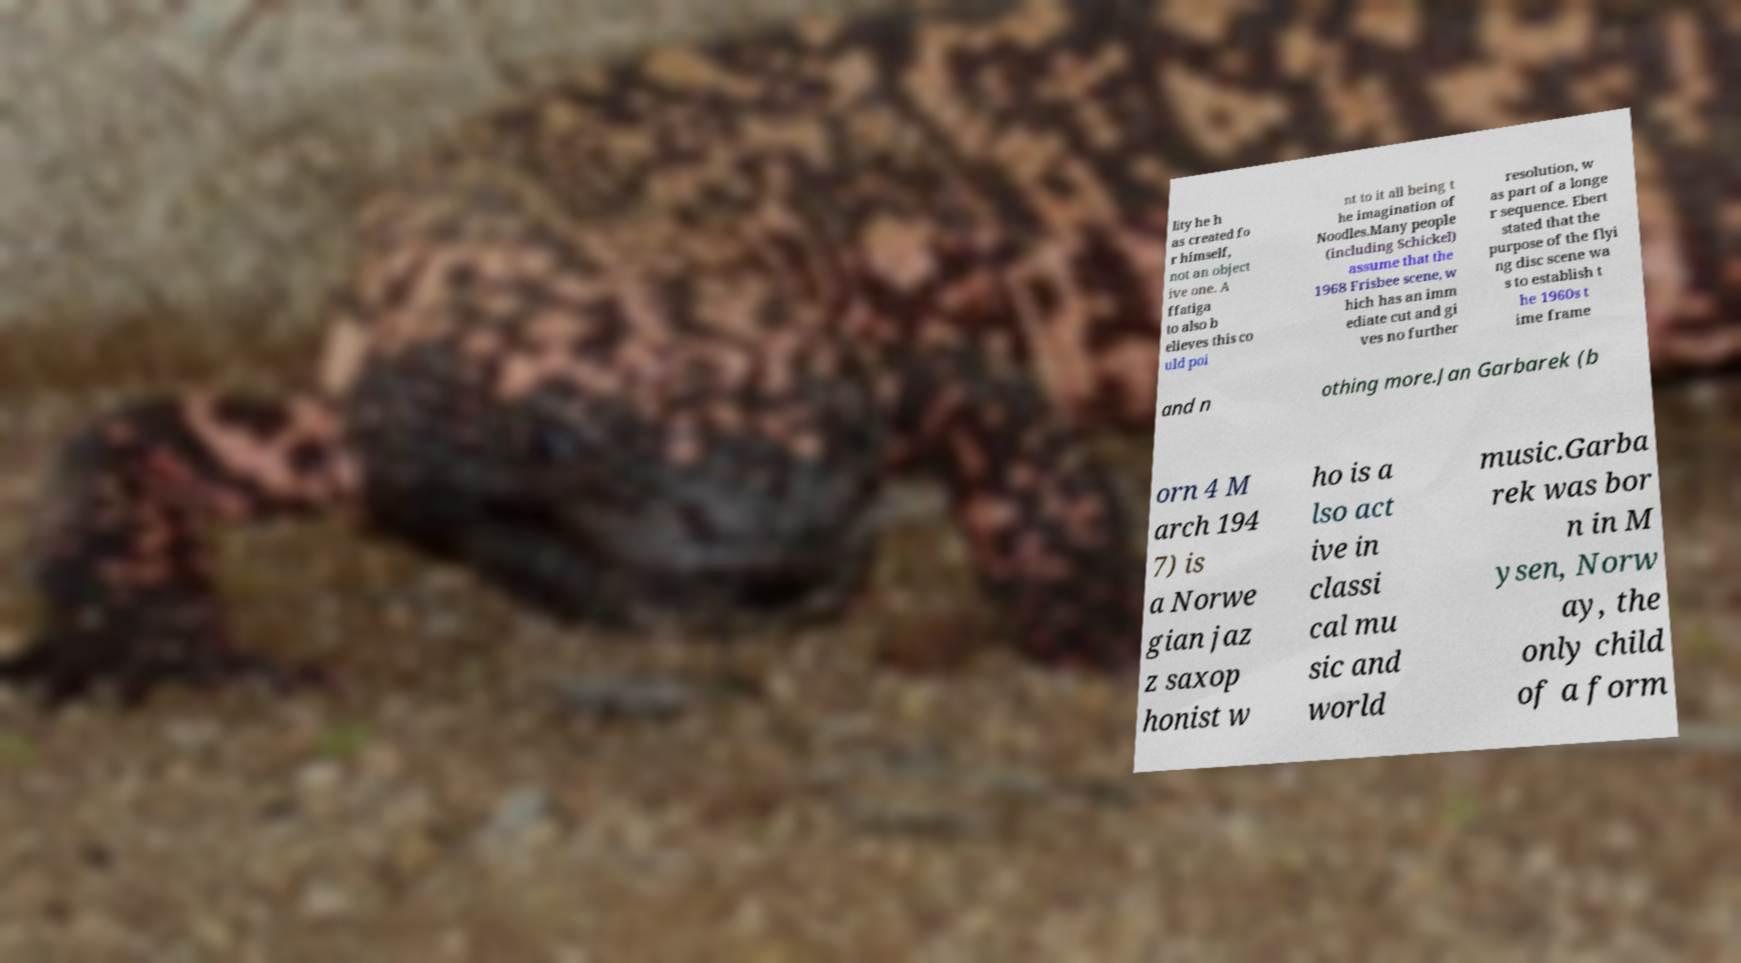Can you read and provide the text displayed in the image?This photo seems to have some interesting text. Can you extract and type it out for me? lity he h as created fo r himself, not an object ive one. A ffatiga to also b elieves this co uld poi nt to it all being t he imagination of Noodles.Many people (including Schickel) assume that the 1968 Frisbee scene, w hich has an imm ediate cut and gi ves no further resolution, w as part of a longe r sequence. Ebert stated that the purpose of the flyi ng disc scene wa s to establish t he 1960s t ime frame and n othing more.Jan Garbarek (b orn 4 M arch 194 7) is a Norwe gian jaz z saxop honist w ho is a lso act ive in classi cal mu sic and world music.Garba rek was bor n in M ysen, Norw ay, the only child of a form 